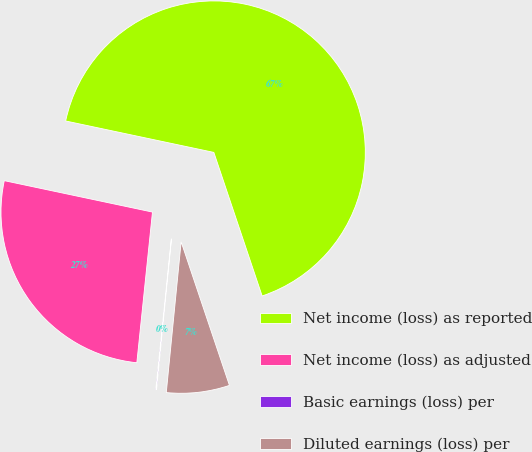<chart> <loc_0><loc_0><loc_500><loc_500><pie_chart><fcel>Net income (loss) as reported<fcel>Net income (loss) as adjusted<fcel>Basic earnings (loss) per<fcel>Diluted earnings (loss) per<nl><fcel>66.51%<fcel>26.68%<fcel>0.08%<fcel>6.73%<nl></chart> 